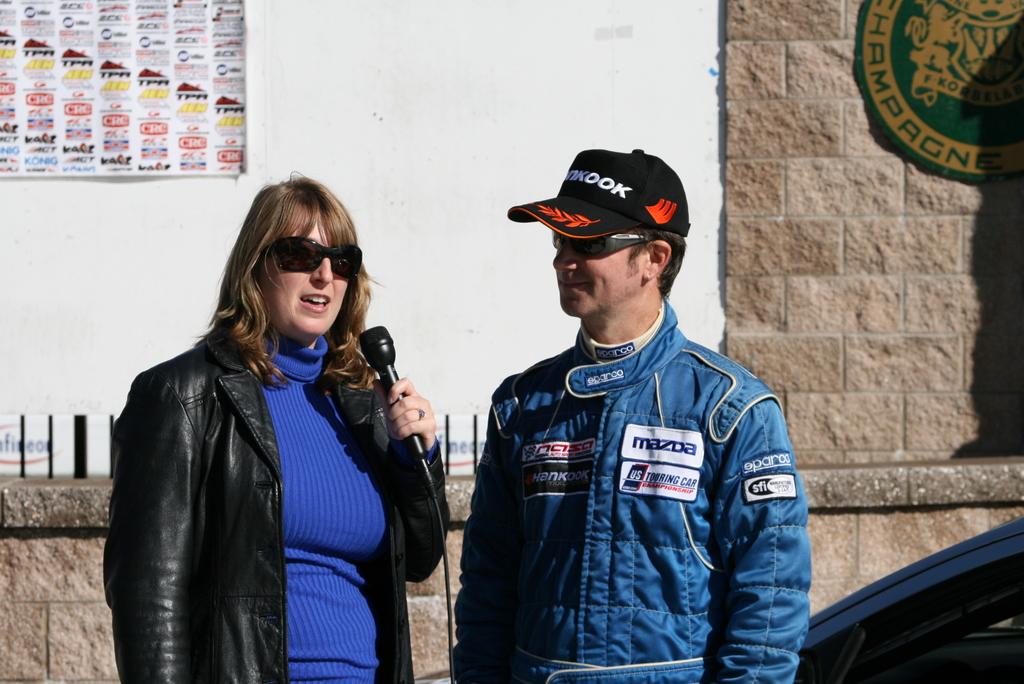What is the brand name on the driver's hat?
Ensure brevity in your answer.  Hankook. What auto manufacturer sponsors this driver?
Give a very brief answer. Mazda. 